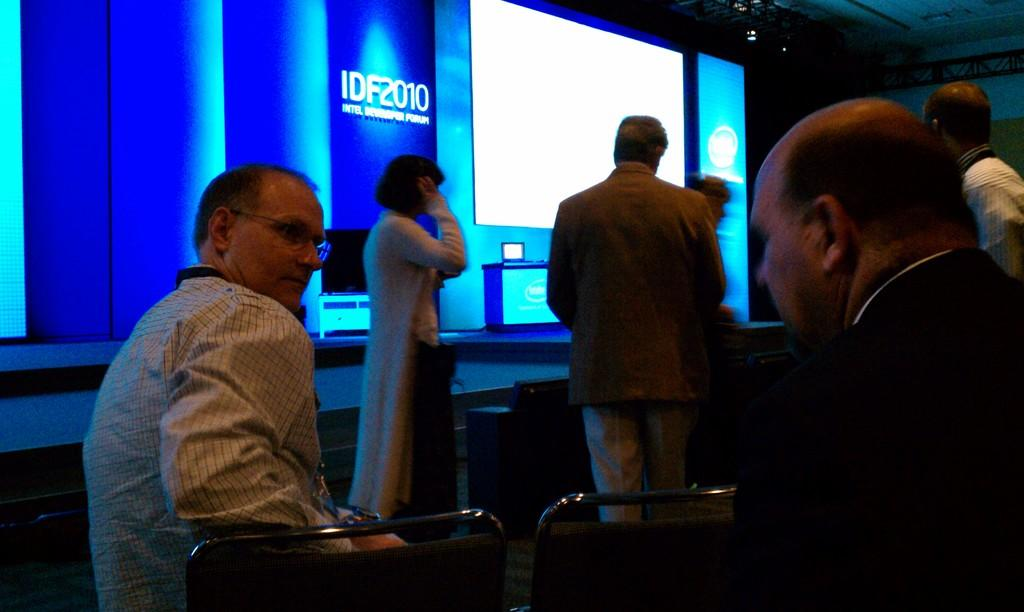How many people are present in the image? There are six people in the image, two sitting and four standing. What are the sitting persons doing? The sitting persons are in chairs. What can be seen in the background of the image? There is a projector and other objects visible in the background. What might the standing persons be doing in relation to the sitting persons? The standing persons might be presenting or discussing something with the sitting persons, given the presence of a projector. Can you tell me how many baby suits are visible in the image? There is no baby or suit present in the image. What type of yard is visible in the image? There is no yard visible in the image. 